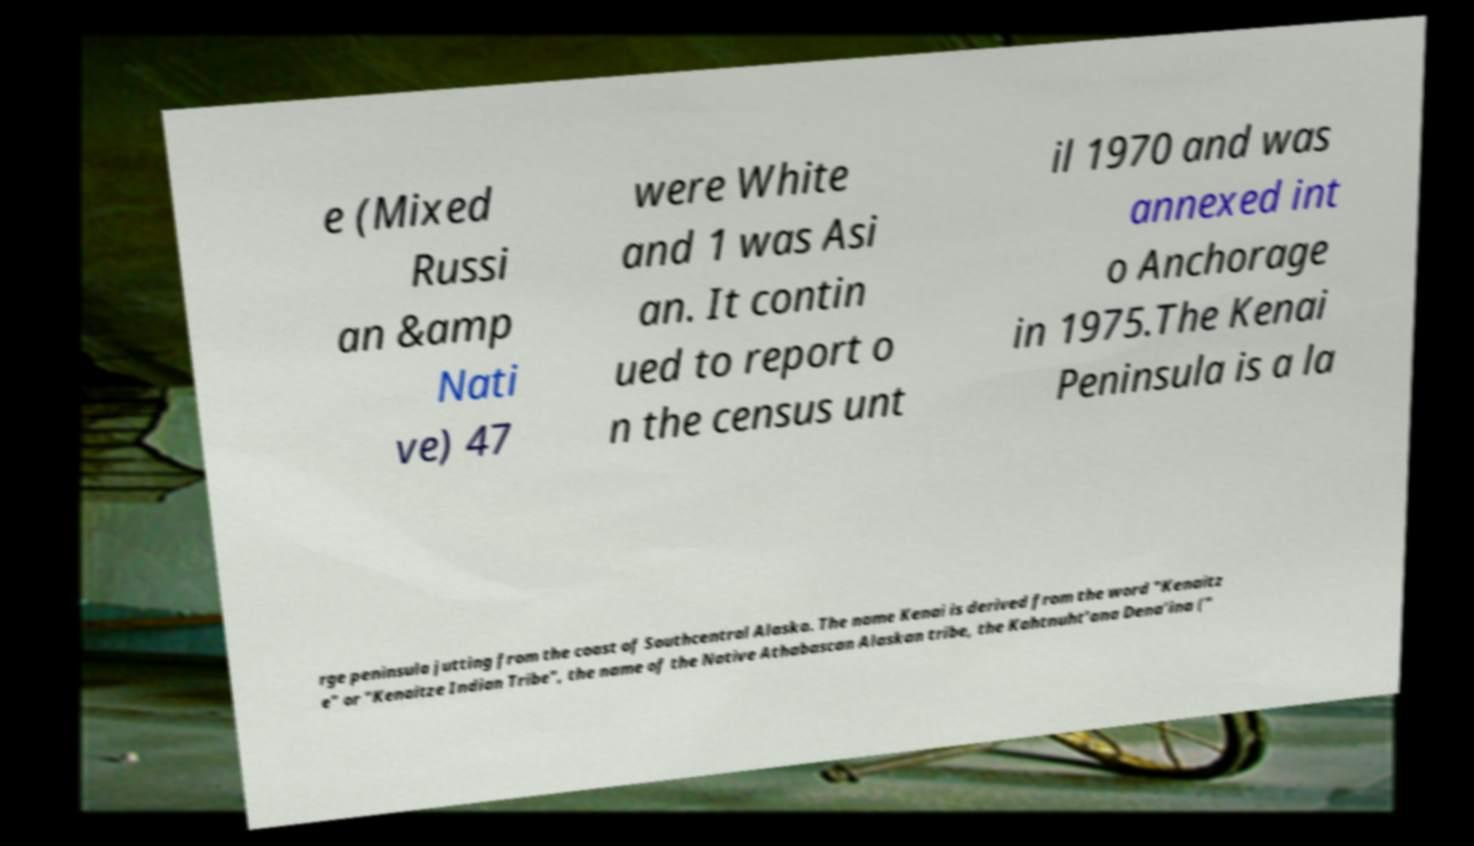Please identify and transcribe the text found in this image. e (Mixed Russi an &amp Nati ve) 47 were White and 1 was Asi an. It contin ued to report o n the census unt il 1970 and was annexed int o Anchorage in 1975.The Kenai Peninsula is a la rge peninsula jutting from the coast of Southcentral Alaska. The name Kenai is derived from the word "Kenaitz e" or "Kenaitze Indian Tribe", the name of the Native Athabascan Alaskan tribe, the Kahtnuht’ana Dena’ina (" 